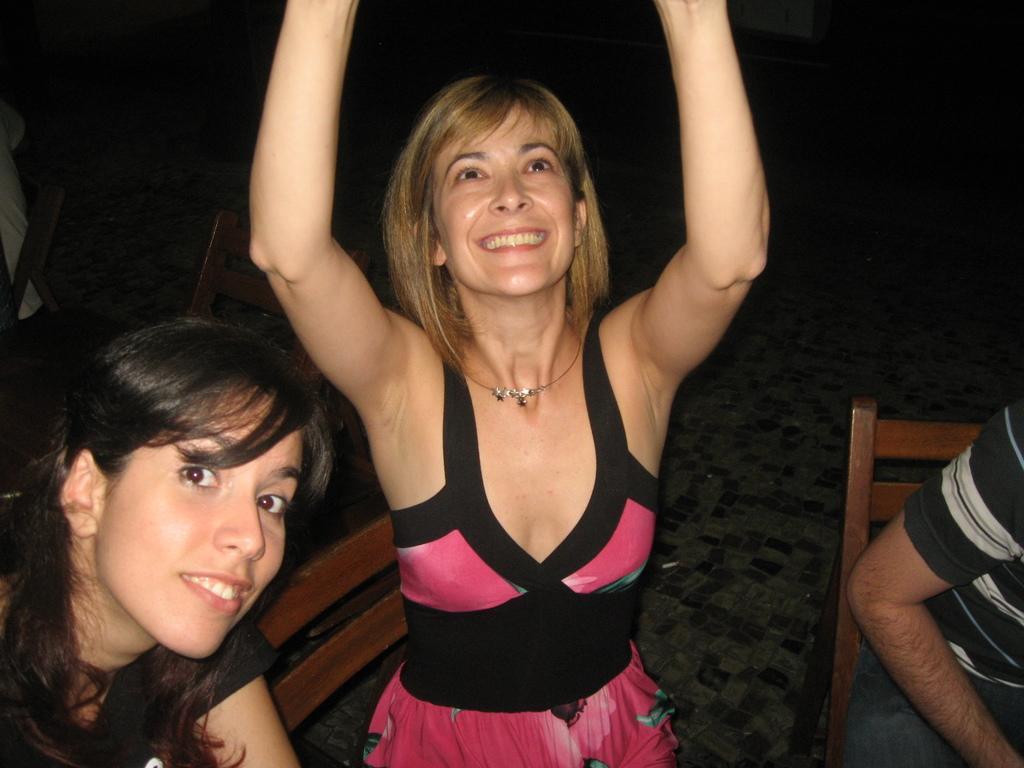Can you describe this image briefly? In this image I see 2 women and I see a man over here who is sitting on a chair and I see another chair over here and I see that these 2 women are smiling and I see that this woman is wearing pink and black dress and I see another person sitting on this chair and it is dark in the background and I see the floor over here. 